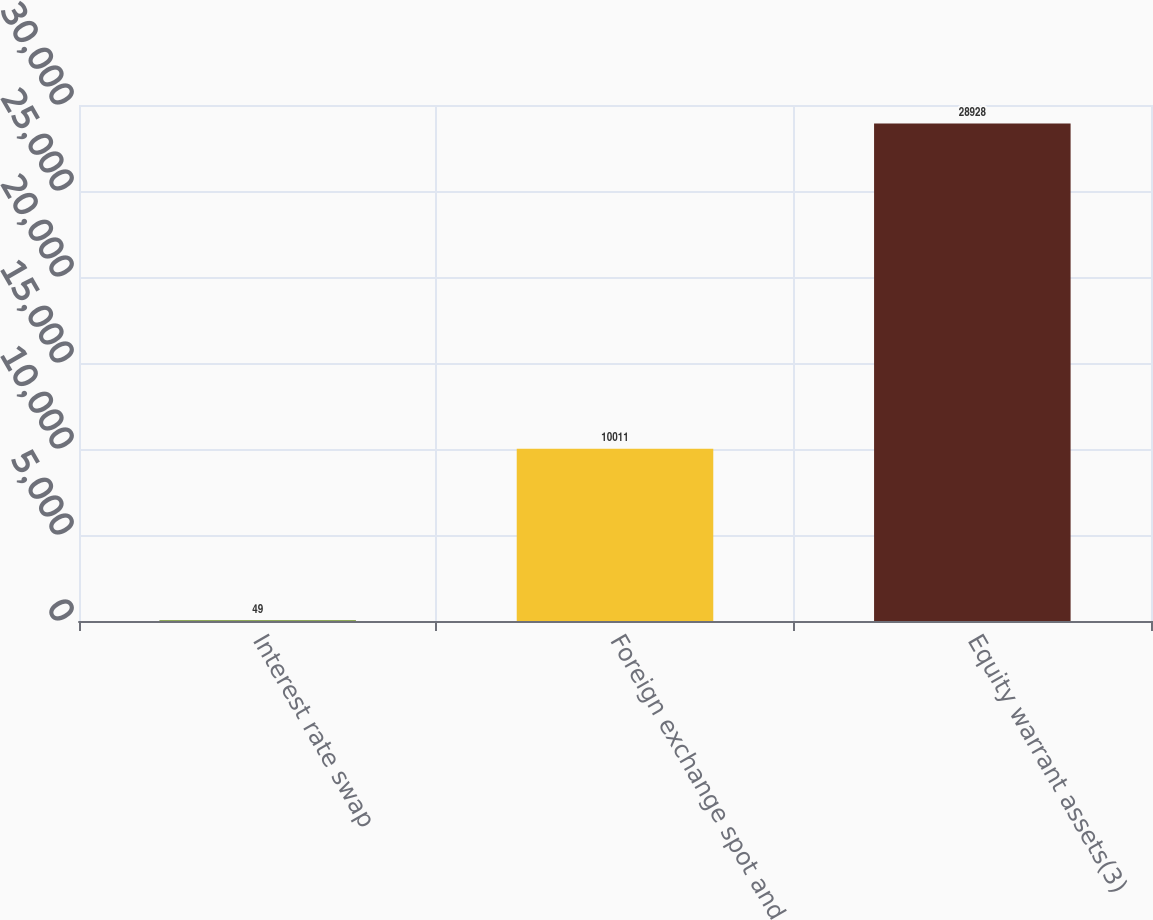Convert chart to OTSL. <chart><loc_0><loc_0><loc_500><loc_500><bar_chart><fcel>Interest rate swap<fcel>Foreign exchange spot and<fcel>Equity warrant assets(3)<nl><fcel>49<fcel>10011<fcel>28928<nl></chart> 